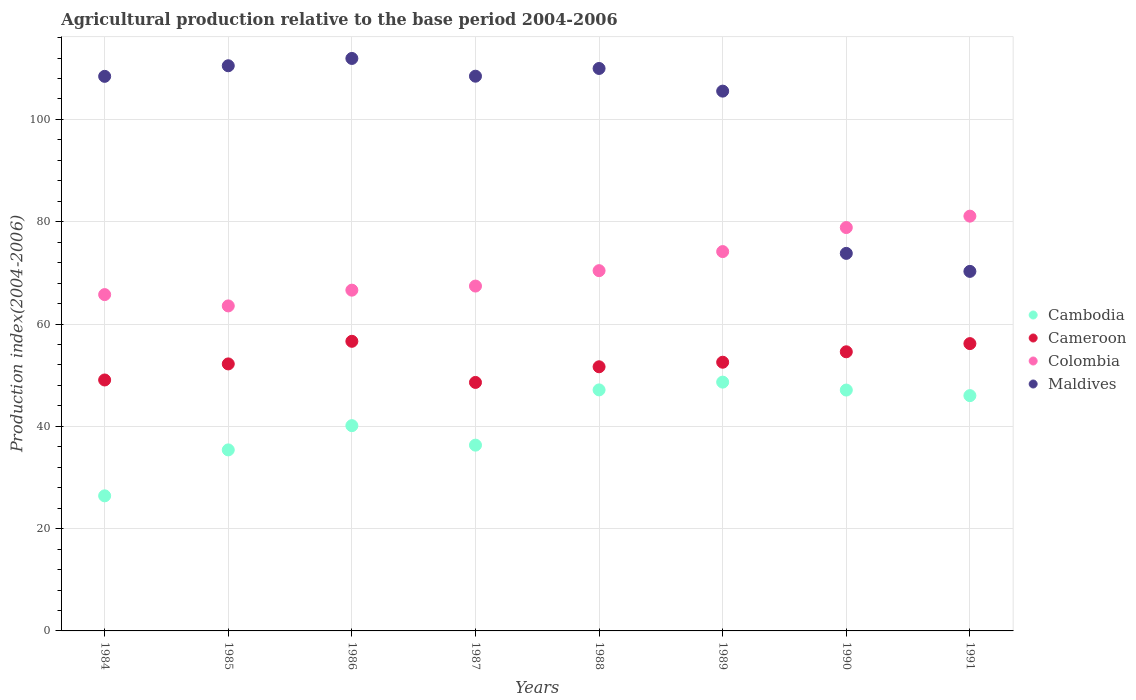How many different coloured dotlines are there?
Provide a short and direct response. 4. Is the number of dotlines equal to the number of legend labels?
Keep it short and to the point. Yes. What is the agricultural production index in Cambodia in 1988?
Your answer should be very brief. 47.12. Across all years, what is the maximum agricultural production index in Cambodia?
Ensure brevity in your answer.  48.64. Across all years, what is the minimum agricultural production index in Colombia?
Keep it short and to the point. 63.54. In which year was the agricultural production index in Cameroon maximum?
Your answer should be compact. 1986. In which year was the agricultural production index in Cameroon minimum?
Give a very brief answer. 1987. What is the total agricultural production index in Cameroon in the graph?
Your answer should be compact. 421.37. What is the difference between the agricultural production index in Cambodia in 1986 and that in 1991?
Your answer should be very brief. -5.87. What is the difference between the agricultural production index in Cambodia in 1984 and the agricultural production index in Maldives in 1988?
Provide a short and direct response. -83.55. What is the average agricultural production index in Colombia per year?
Give a very brief answer. 70.98. In the year 1991, what is the difference between the agricultural production index in Cambodia and agricultural production index in Colombia?
Provide a short and direct response. -35.09. What is the ratio of the agricultural production index in Cambodia in 1985 to that in 1991?
Give a very brief answer. 0.77. Is the agricultural production index in Maldives in 1984 less than that in 1988?
Your response must be concise. Yes. What is the difference between the highest and the second highest agricultural production index in Maldives?
Ensure brevity in your answer.  1.43. What is the difference between the highest and the lowest agricultural production index in Cambodia?
Keep it short and to the point. 22.23. In how many years, is the agricultural production index in Maldives greater than the average agricultural production index in Maldives taken over all years?
Make the answer very short. 6. Is the sum of the agricultural production index in Cameroon in 1987 and 1988 greater than the maximum agricultural production index in Cambodia across all years?
Your answer should be very brief. Yes. Does the agricultural production index in Cambodia monotonically increase over the years?
Give a very brief answer. No. Is the agricultural production index in Colombia strictly greater than the agricultural production index in Maldives over the years?
Keep it short and to the point. No. Is the agricultural production index in Colombia strictly less than the agricultural production index in Cambodia over the years?
Keep it short and to the point. No. How many dotlines are there?
Provide a succinct answer. 4. Does the graph contain any zero values?
Give a very brief answer. No. Does the graph contain grids?
Ensure brevity in your answer.  Yes. Where does the legend appear in the graph?
Keep it short and to the point. Center right. What is the title of the graph?
Provide a succinct answer. Agricultural production relative to the base period 2004-2006. What is the label or title of the Y-axis?
Your response must be concise. Production index(2004-2006). What is the Production index(2004-2006) of Cambodia in 1984?
Offer a terse response. 26.41. What is the Production index(2004-2006) in Cameroon in 1984?
Offer a very short reply. 49.06. What is the Production index(2004-2006) of Colombia in 1984?
Give a very brief answer. 65.75. What is the Production index(2004-2006) in Maldives in 1984?
Your answer should be compact. 108.42. What is the Production index(2004-2006) of Cambodia in 1985?
Provide a short and direct response. 35.39. What is the Production index(2004-2006) in Cameroon in 1985?
Your answer should be compact. 52.2. What is the Production index(2004-2006) in Colombia in 1985?
Offer a terse response. 63.54. What is the Production index(2004-2006) of Maldives in 1985?
Make the answer very short. 110.49. What is the Production index(2004-2006) in Cambodia in 1986?
Your response must be concise. 40.13. What is the Production index(2004-2006) in Cameroon in 1986?
Your answer should be compact. 56.62. What is the Production index(2004-2006) in Colombia in 1986?
Give a very brief answer. 66.62. What is the Production index(2004-2006) of Maldives in 1986?
Provide a short and direct response. 111.92. What is the Production index(2004-2006) in Cambodia in 1987?
Your response must be concise. 36.32. What is the Production index(2004-2006) in Cameroon in 1987?
Provide a succinct answer. 48.58. What is the Production index(2004-2006) of Colombia in 1987?
Make the answer very short. 67.42. What is the Production index(2004-2006) in Maldives in 1987?
Keep it short and to the point. 108.45. What is the Production index(2004-2006) in Cambodia in 1988?
Give a very brief answer. 47.12. What is the Production index(2004-2006) of Cameroon in 1988?
Provide a succinct answer. 51.64. What is the Production index(2004-2006) of Colombia in 1988?
Offer a very short reply. 70.43. What is the Production index(2004-2006) in Maldives in 1988?
Provide a succinct answer. 109.96. What is the Production index(2004-2006) in Cambodia in 1989?
Keep it short and to the point. 48.64. What is the Production index(2004-2006) in Cameroon in 1989?
Your response must be concise. 52.53. What is the Production index(2004-2006) of Colombia in 1989?
Your response must be concise. 74.16. What is the Production index(2004-2006) of Maldives in 1989?
Make the answer very short. 105.53. What is the Production index(2004-2006) in Cambodia in 1990?
Your response must be concise. 47.09. What is the Production index(2004-2006) of Cameroon in 1990?
Provide a short and direct response. 54.57. What is the Production index(2004-2006) in Colombia in 1990?
Your answer should be very brief. 78.86. What is the Production index(2004-2006) of Maldives in 1990?
Provide a succinct answer. 73.81. What is the Production index(2004-2006) of Cambodia in 1991?
Your answer should be very brief. 46. What is the Production index(2004-2006) in Cameroon in 1991?
Ensure brevity in your answer.  56.17. What is the Production index(2004-2006) of Colombia in 1991?
Provide a succinct answer. 81.09. What is the Production index(2004-2006) of Maldives in 1991?
Your response must be concise. 70.29. Across all years, what is the maximum Production index(2004-2006) of Cambodia?
Offer a very short reply. 48.64. Across all years, what is the maximum Production index(2004-2006) in Cameroon?
Your answer should be very brief. 56.62. Across all years, what is the maximum Production index(2004-2006) in Colombia?
Provide a succinct answer. 81.09. Across all years, what is the maximum Production index(2004-2006) in Maldives?
Offer a terse response. 111.92. Across all years, what is the minimum Production index(2004-2006) in Cambodia?
Your answer should be compact. 26.41. Across all years, what is the minimum Production index(2004-2006) in Cameroon?
Your response must be concise. 48.58. Across all years, what is the minimum Production index(2004-2006) of Colombia?
Make the answer very short. 63.54. Across all years, what is the minimum Production index(2004-2006) of Maldives?
Offer a very short reply. 70.29. What is the total Production index(2004-2006) of Cambodia in the graph?
Ensure brevity in your answer.  327.1. What is the total Production index(2004-2006) in Cameroon in the graph?
Ensure brevity in your answer.  421.37. What is the total Production index(2004-2006) in Colombia in the graph?
Your response must be concise. 567.87. What is the total Production index(2004-2006) in Maldives in the graph?
Provide a short and direct response. 798.87. What is the difference between the Production index(2004-2006) of Cambodia in 1984 and that in 1985?
Offer a very short reply. -8.98. What is the difference between the Production index(2004-2006) of Cameroon in 1984 and that in 1985?
Your answer should be compact. -3.14. What is the difference between the Production index(2004-2006) of Colombia in 1984 and that in 1985?
Provide a succinct answer. 2.21. What is the difference between the Production index(2004-2006) in Maldives in 1984 and that in 1985?
Keep it short and to the point. -2.07. What is the difference between the Production index(2004-2006) in Cambodia in 1984 and that in 1986?
Ensure brevity in your answer.  -13.72. What is the difference between the Production index(2004-2006) in Cameroon in 1984 and that in 1986?
Offer a terse response. -7.56. What is the difference between the Production index(2004-2006) in Colombia in 1984 and that in 1986?
Your answer should be compact. -0.87. What is the difference between the Production index(2004-2006) in Maldives in 1984 and that in 1986?
Offer a very short reply. -3.5. What is the difference between the Production index(2004-2006) of Cambodia in 1984 and that in 1987?
Provide a succinct answer. -9.91. What is the difference between the Production index(2004-2006) of Cameroon in 1984 and that in 1987?
Your response must be concise. 0.48. What is the difference between the Production index(2004-2006) of Colombia in 1984 and that in 1987?
Give a very brief answer. -1.67. What is the difference between the Production index(2004-2006) of Maldives in 1984 and that in 1987?
Your answer should be very brief. -0.03. What is the difference between the Production index(2004-2006) of Cambodia in 1984 and that in 1988?
Offer a very short reply. -20.71. What is the difference between the Production index(2004-2006) in Cameroon in 1984 and that in 1988?
Your answer should be compact. -2.58. What is the difference between the Production index(2004-2006) of Colombia in 1984 and that in 1988?
Make the answer very short. -4.68. What is the difference between the Production index(2004-2006) of Maldives in 1984 and that in 1988?
Your answer should be very brief. -1.54. What is the difference between the Production index(2004-2006) of Cambodia in 1984 and that in 1989?
Ensure brevity in your answer.  -22.23. What is the difference between the Production index(2004-2006) of Cameroon in 1984 and that in 1989?
Your answer should be very brief. -3.47. What is the difference between the Production index(2004-2006) of Colombia in 1984 and that in 1989?
Your response must be concise. -8.41. What is the difference between the Production index(2004-2006) in Maldives in 1984 and that in 1989?
Keep it short and to the point. 2.89. What is the difference between the Production index(2004-2006) in Cambodia in 1984 and that in 1990?
Give a very brief answer. -20.68. What is the difference between the Production index(2004-2006) of Cameroon in 1984 and that in 1990?
Keep it short and to the point. -5.51. What is the difference between the Production index(2004-2006) in Colombia in 1984 and that in 1990?
Ensure brevity in your answer.  -13.11. What is the difference between the Production index(2004-2006) in Maldives in 1984 and that in 1990?
Provide a short and direct response. 34.61. What is the difference between the Production index(2004-2006) of Cambodia in 1984 and that in 1991?
Offer a very short reply. -19.59. What is the difference between the Production index(2004-2006) in Cameroon in 1984 and that in 1991?
Offer a terse response. -7.11. What is the difference between the Production index(2004-2006) of Colombia in 1984 and that in 1991?
Your response must be concise. -15.34. What is the difference between the Production index(2004-2006) in Maldives in 1984 and that in 1991?
Offer a terse response. 38.13. What is the difference between the Production index(2004-2006) in Cambodia in 1985 and that in 1986?
Your response must be concise. -4.74. What is the difference between the Production index(2004-2006) of Cameroon in 1985 and that in 1986?
Offer a terse response. -4.42. What is the difference between the Production index(2004-2006) in Colombia in 1985 and that in 1986?
Ensure brevity in your answer.  -3.08. What is the difference between the Production index(2004-2006) of Maldives in 1985 and that in 1986?
Ensure brevity in your answer.  -1.43. What is the difference between the Production index(2004-2006) of Cambodia in 1985 and that in 1987?
Offer a very short reply. -0.93. What is the difference between the Production index(2004-2006) of Cameroon in 1985 and that in 1987?
Your answer should be compact. 3.62. What is the difference between the Production index(2004-2006) in Colombia in 1985 and that in 1987?
Offer a very short reply. -3.88. What is the difference between the Production index(2004-2006) of Maldives in 1985 and that in 1987?
Offer a very short reply. 2.04. What is the difference between the Production index(2004-2006) in Cambodia in 1985 and that in 1988?
Make the answer very short. -11.73. What is the difference between the Production index(2004-2006) of Cameroon in 1985 and that in 1988?
Offer a very short reply. 0.56. What is the difference between the Production index(2004-2006) in Colombia in 1985 and that in 1988?
Keep it short and to the point. -6.89. What is the difference between the Production index(2004-2006) of Maldives in 1985 and that in 1988?
Keep it short and to the point. 0.53. What is the difference between the Production index(2004-2006) of Cambodia in 1985 and that in 1989?
Provide a succinct answer. -13.25. What is the difference between the Production index(2004-2006) in Cameroon in 1985 and that in 1989?
Ensure brevity in your answer.  -0.33. What is the difference between the Production index(2004-2006) in Colombia in 1985 and that in 1989?
Your response must be concise. -10.62. What is the difference between the Production index(2004-2006) of Maldives in 1985 and that in 1989?
Your answer should be very brief. 4.96. What is the difference between the Production index(2004-2006) in Cameroon in 1985 and that in 1990?
Your answer should be compact. -2.37. What is the difference between the Production index(2004-2006) of Colombia in 1985 and that in 1990?
Ensure brevity in your answer.  -15.32. What is the difference between the Production index(2004-2006) of Maldives in 1985 and that in 1990?
Keep it short and to the point. 36.68. What is the difference between the Production index(2004-2006) of Cambodia in 1985 and that in 1991?
Offer a terse response. -10.61. What is the difference between the Production index(2004-2006) of Cameroon in 1985 and that in 1991?
Your answer should be compact. -3.97. What is the difference between the Production index(2004-2006) of Colombia in 1985 and that in 1991?
Your response must be concise. -17.55. What is the difference between the Production index(2004-2006) in Maldives in 1985 and that in 1991?
Give a very brief answer. 40.2. What is the difference between the Production index(2004-2006) of Cambodia in 1986 and that in 1987?
Your answer should be compact. 3.81. What is the difference between the Production index(2004-2006) of Cameroon in 1986 and that in 1987?
Give a very brief answer. 8.04. What is the difference between the Production index(2004-2006) in Maldives in 1986 and that in 1987?
Provide a short and direct response. 3.47. What is the difference between the Production index(2004-2006) in Cambodia in 1986 and that in 1988?
Provide a short and direct response. -6.99. What is the difference between the Production index(2004-2006) of Cameroon in 1986 and that in 1988?
Offer a very short reply. 4.98. What is the difference between the Production index(2004-2006) in Colombia in 1986 and that in 1988?
Give a very brief answer. -3.81. What is the difference between the Production index(2004-2006) of Maldives in 1986 and that in 1988?
Offer a very short reply. 1.96. What is the difference between the Production index(2004-2006) in Cambodia in 1986 and that in 1989?
Offer a terse response. -8.51. What is the difference between the Production index(2004-2006) in Cameroon in 1986 and that in 1989?
Give a very brief answer. 4.09. What is the difference between the Production index(2004-2006) in Colombia in 1986 and that in 1989?
Make the answer very short. -7.54. What is the difference between the Production index(2004-2006) of Maldives in 1986 and that in 1989?
Provide a short and direct response. 6.39. What is the difference between the Production index(2004-2006) in Cambodia in 1986 and that in 1990?
Your response must be concise. -6.96. What is the difference between the Production index(2004-2006) of Cameroon in 1986 and that in 1990?
Your response must be concise. 2.05. What is the difference between the Production index(2004-2006) of Colombia in 1986 and that in 1990?
Your answer should be compact. -12.24. What is the difference between the Production index(2004-2006) in Maldives in 1986 and that in 1990?
Provide a succinct answer. 38.11. What is the difference between the Production index(2004-2006) of Cambodia in 1986 and that in 1991?
Provide a succinct answer. -5.87. What is the difference between the Production index(2004-2006) of Cameroon in 1986 and that in 1991?
Your answer should be compact. 0.45. What is the difference between the Production index(2004-2006) of Colombia in 1986 and that in 1991?
Your answer should be compact. -14.47. What is the difference between the Production index(2004-2006) in Maldives in 1986 and that in 1991?
Offer a terse response. 41.63. What is the difference between the Production index(2004-2006) in Cambodia in 1987 and that in 1988?
Provide a succinct answer. -10.8. What is the difference between the Production index(2004-2006) in Cameroon in 1987 and that in 1988?
Your response must be concise. -3.06. What is the difference between the Production index(2004-2006) in Colombia in 1987 and that in 1988?
Offer a very short reply. -3.01. What is the difference between the Production index(2004-2006) of Maldives in 1987 and that in 1988?
Keep it short and to the point. -1.51. What is the difference between the Production index(2004-2006) in Cambodia in 1987 and that in 1989?
Offer a terse response. -12.32. What is the difference between the Production index(2004-2006) of Cameroon in 1987 and that in 1989?
Your answer should be compact. -3.95. What is the difference between the Production index(2004-2006) in Colombia in 1987 and that in 1989?
Your answer should be compact. -6.74. What is the difference between the Production index(2004-2006) of Maldives in 1987 and that in 1989?
Your answer should be compact. 2.92. What is the difference between the Production index(2004-2006) of Cambodia in 1987 and that in 1990?
Offer a very short reply. -10.77. What is the difference between the Production index(2004-2006) in Cameroon in 1987 and that in 1990?
Give a very brief answer. -5.99. What is the difference between the Production index(2004-2006) in Colombia in 1987 and that in 1990?
Make the answer very short. -11.44. What is the difference between the Production index(2004-2006) of Maldives in 1987 and that in 1990?
Your response must be concise. 34.64. What is the difference between the Production index(2004-2006) of Cambodia in 1987 and that in 1991?
Your response must be concise. -9.68. What is the difference between the Production index(2004-2006) of Cameroon in 1987 and that in 1991?
Offer a very short reply. -7.59. What is the difference between the Production index(2004-2006) of Colombia in 1987 and that in 1991?
Provide a succinct answer. -13.67. What is the difference between the Production index(2004-2006) of Maldives in 1987 and that in 1991?
Offer a terse response. 38.16. What is the difference between the Production index(2004-2006) of Cambodia in 1988 and that in 1989?
Ensure brevity in your answer.  -1.52. What is the difference between the Production index(2004-2006) in Cameroon in 1988 and that in 1989?
Your answer should be compact. -0.89. What is the difference between the Production index(2004-2006) in Colombia in 1988 and that in 1989?
Make the answer very short. -3.73. What is the difference between the Production index(2004-2006) in Maldives in 1988 and that in 1989?
Ensure brevity in your answer.  4.43. What is the difference between the Production index(2004-2006) of Cameroon in 1988 and that in 1990?
Your answer should be compact. -2.93. What is the difference between the Production index(2004-2006) in Colombia in 1988 and that in 1990?
Provide a succinct answer. -8.43. What is the difference between the Production index(2004-2006) in Maldives in 1988 and that in 1990?
Keep it short and to the point. 36.15. What is the difference between the Production index(2004-2006) in Cambodia in 1988 and that in 1991?
Provide a short and direct response. 1.12. What is the difference between the Production index(2004-2006) of Cameroon in 1988 and that in 1991?
Keep it short and to the point. -4.53. What is the difference between the Production index(2004-2006) in Colombia in 1988 and that in 1991?
Ensure brevity in your answer.  -10.66. What is the difference between the Production index(2004-2006) of Maldives in 1988 and that in 1991?
Give a very brief answer. 39.67. What is the difference between the Production index(2004-2006) of Cambodia in 1989 and that in 1990?
Your response must be concise. 1.55. What is the difference between the Production index(2004-2006) in Cameroon in 1989 and that in 1990?
Ensure brevity in your answer.  -2.04. What is the difference between the Production index(2004-2006) of Colombia in 1989 and that in 1990?
Give a very brief answer. -4.7. What is the difference between the Production index(2004-2006) of Maldives in 1989 and that in 1990?
Offer a terse response. 31.72. What is the difference between the Production index(2004-2006) of Cambodia in 1989 and that in 1991?
Provide a succinct answer. 2.64. What is the difference between the Production index(2004-2006) in Cameroon in 1989 and that in 1991?
Make the answer very short. -3.64. What is the difference between the Production index(2004-2006) in Colombia in 1989 and that in 1991?
Your response must be concise. -6.93. What is the difference between the Production index(2004-2006) in Maldives in 1989 and that in 1991?
Give a very brief answer. 35.24. What is the difference between the Production index(2004-2006) in Cambodia in 1990 and that in 1991?
Ensure brevity in your answer.  1.09. What is the difference between the Production index(2004-2006) in Cameroon in 1990 and that in 1991?
Give a very brief answer. -1.6. What is the difference between the Production index(2004-2006) in Colombia in 1990 and that in 1991?
Your answer should be compact. -2.23. What is the difference between the Production index(2004-2006) in Maldives in 1990 and that in 1991?
Offer a terse response. 3.52. What is the difference between the Production index(2004-2006) of Cambodia in 1984 and the Production index(2004-2006) of Cameroon in 1985?
Keep it short and to the point. -25.79. What is the difference between the Production index(2004-2006) in Cambodia in 1984 and the Production index(2004-2006) in Colombia in 1985?
Provide a short and direct response. -37.13. What is the difference between the Production index(2004-2006) of Cambodia in 1984 and the Production index(2004-2006) of Maldives in 1985?
Your response must be concise. -84.08. What is the difference between the Production index(2004-2006) of Cameroon in 1984 and the Production index(2004-2006) of Colombia in 1985?
Provide a succinct answer. -14.48. What is the difference between the Production index(2004-2006) of Cameroon in 1984 and the Production index(2004-2006) of Maldives in 1985?
Offer a terse response. -61.43. What is the difference between the Production index(2004-2006) in Colombia in 1984 and the Production index(2004-2006) in Maldives in 1985?
Your answer should be very brief. -44.74. What is the difference between the Production index(2004-2006) in Cambodia in 1984 and the Production index(2004-2006) in Cameroon in 1986?
Keep it short and to the point. -30.21. What is the difference between the Production index(2004-2006) of Cambodia in 1984 and the Production index(2004-2006) of Colombia in 1986?
Offer a terse response. -40.21. What is the difference between the Production index(2004-2006) of Cambodia in 1984 and the Production index(2004-2006) of Maldives in 1986?
Give a very brief answer. -85.51. What is the difference between the Production index(2004-2006) in Cameroon in 1984 and the Production index(2004-2006) in Colombia in 1986?
Your answer should be very brief. -17.56. What is the difference between the Production index(2004-2006) in Cameroon in 1984 and the Production index(2004-2006) in Maldives in 1986?
Provide a succinct answer. -62.86. What is the difference between the Production index(2004-2006) of Colombia in 1984 and the Production index(2004-2006) of Maldives in 1986?
Keep it short and to the point. -46.17. What is the difference between the Production index(2004-2006) of Cambodia in 1984 and the Production index(2004-2006) of Cameroon in 1987?
Your response must be concise. -22.17. What is the difference between the Production index(2004-2006) of Cambodia in 1984 and the Production index(2004-2006) of Colombia in 1987?
Make the answer very short. -41.01. What is the difference between the Production index(2004-2006) of Cambodia in 1984 and the Production index(2004-2006) of Maldives in 1987?
Your answer should be very brief. -82.04. What is the difference between the Production index(2004-2006) in Cameroon in 1984 and the Production index(2004-2006) in Colombia in 1987?
Keep it short and to the point. -18.36. What is the difference between the Production index(2004-2006) of Cameroon in 1984 and the Production index(2004-2006) of Maldives in 1987?
Provide a short and direct response. -59.39. What is the difference between the Production index(2004-2006) in Colombia in 1984 and the Production index(2004-2006) in Maldives in 1987?
Your answer should be compact. -42.7. What is the difference between the Production index(2004-2006) of Cambodia in 1984 and the Production index(2004-2006) of Cameroon in 1988?
Ensure brevity in your answer.  -25.23. What is the difference between the Production index(2004-2006) of Cambodia in 1984 and the Production index(2004-2006) of Colombia in 1988?
Your response must be concise. -44.02. What is the difference between the Production index(2004-2006) in Cambodia in 1984 and the Production index(2004-2006) in Maldives in 1988?
Your response must be concise. -83.55. What is the difference between the Production index(2004-2006) of Cameroon in 1984 and the Production index(2004-2006) of Colombia in 1988?
Give a very brief answer. -21.37. What is the difference between the Production index(2004-2006) in Cameroon in 1984 and the Production index(2004-2006) in Maldives in 1988?
Offer a very short reply. -60.9. What is the difference between the Production index(2004-2006) in Colombia in 1984 and the Production index(2004-2006) in Maldives in 1988?
Keep it short and to the point. -44.21. What is the difference between the Production index(2004-2006) in Cambodia in 1984 and the Production index(2004-2006) in Cameroon in 1989?
Your response must be concise. -26.12. What is the difference between the Production index(2004-2006) of Cambodia in 1984 and the Production index(2004-2006) of Colombia in 1989?
Offer a very short reply. -47.75. What is the difference between the Production index(2004-2006) in Cambodia in 1984 and the Production index(2004-2006) in Maldives in 1989?
Offer a terse response. -79.12. What is the difference between the Production index(2004-2006) in Cameroon in 1984 and the Production index(2004-2006) in Colombia in 1989?
Offer a terse response. -25.1. What is the difference between the Production index(2004-2006) in Cameroon in 1984 and the Production index(2004-2006) in Maldives in 1989?
Provide a succinct answer. -56.47. What is the difference between the Production index(2004-2006) of Colombia in 1984 and the Production index(2004-2006) of Maldives in 1989?
Give a very brief answer. -39.78. What is the difference between the Production index(2004-2006) of Cambodia in 1984 and the Production index(2004-2006) of Cameroon in 1990?
Offer a terse response. -28.16. What is the difference between the Production index(2004-2006) in Cambodia in 1984 and the Production index(2004-2006) in Colombia in 1990?
Give a very brief answer. -52.45. What is the difference between the Production index(2004-2006) of Cambodia in 1984 and the Production index(2004-2006) of Maldives in 1990?
Provide a short and direct response. -47.4. What is the difference between the Production index(2004-2006) in Cameroon in 1984 and the Production index(2004-2006) in Colombia in 1990?
Your answer should be compact. -29.8. What is the difference between the Production index(2004-2006) of Cameroon in 1984 and the Production index(2004-2006) of Maldives in 1990?
Give a very brief answer. -24.75. What is the difference between the Production index(2004-2006) in Colombia in 1984 and the Production index(2004-2006) in Maldives in 1990?
Offer a terse response. -8.06. What is the difference between the Production index(2004-2006) in Cambodia in 1984 and the Production index(2004-2006) in Cameroon in 1991?
Provide a short and direct response. -29.76. What is the difference between the Production index(2004-2006) of Cambodia in 1984 and the Production index(2004-2006) of Colombia in 1991?
Keep it short and to the point. -54.68. What is the difference between the Production index(2004-2006) in Cambodia in 1984 and the Production index(2004-2006) in Maldives in 1991?
Make the answer very short. -43.88. What is the difference between the Production index(2004-2006) in Cameroon in 1984 and the Production index(2004-2006) in Colombia in 1991?
Provide a short and direct response. -32.03. What is the difference between the Production index(2004-2006) of Cameroon in 1984 and the Production index(2004-2006) of Maldives in 1991?
Ensure brevity in your answer.  -21.23. What is the difference between the Production index(2004-2006) in Colombia in 1984 and the Production index(2004-2006) in Maldives in 1991?
Provide a short and direct response. -4.54. What is the difference between the Production index(2004-2006) in Cambodia in 1985 and the Production index(2004-2006) in Cameroon in 1986?
Your answer should be very brief. -21.23. What is the difference between the Production index(2004-2006) in Cambodia in 1985 and the Production index(2004-2006) in Colombia in 1986?
Your response must be concise. -31.23. What is the difference between the Production index(2004-2006) in Cambodia in 1985 and the Production index(2004-2006) in Maldives in 1986?
Keep it short and to the point. -76.53. What is the difference between the Production index(2004-2006) of Cameroon in 1985 and the Production index(2004-2006) of Colombia in 1986?
Provide a short and direct response. -14.42. What is the difference between the Production index(2004-2006) in Cameroon in 1985 and the Production index(2004-2006) in Maldives in 1986?
Offer a terse response. -59.72. What is the difference between the Production index(2004-2006) of Colombia in 1985 and the Production index(2004-2006) of Maldives in 1986?
Provide a succinct answer. -48.38. What is the difference between the Production index(2004-2006) in Cambodia in 1985 and the Production index(2004-2006) in Cameroon in 1987?
Offer a terse response. -13.19. What is the difference between the Production index(2004-2006) in Cambodia in 1985 and the Production index(2004-2006) in Colombia in 1987?
Keep it short and to the point. -32.03. What is the difference between the Production index(2004-2006) of Cambodia in 1985 and the Production index(2004-2006) of Maldives in 1987?
Make the answer very short. -73.06. What is the difference between the Production index(2004-2006) in Cameroon in 1985 and the Production index(2004-2006) in Colombia in 1987?
Your response must be concise. -15.22. What is the difference between the Production index(2004-2006) in Cameroon in 1985 and the Production index(2004-2006) in Maldives in 1987?
Keep it short and to the point. -56.25. What is the difference between the Production index(2004-2006) of Colombia in 1985 and the Production index(2004-2006) of Maldives in 1987?
Your response must be concise. -44.91. What is the difference between the Production index(2004-2006) in Cambodia in 1985 and the Production index(2004-2006) in Cameroon in 1988?
Provide a short and direct response. -16.25. What is the difference between the Production index(2004-2006) in Cambodia in 1985 and the Production index(2004-2006) in Colombia in 1988?
Keep it short and to the point. -35.04. What is the difference between the Production index(2004-2006) of Cambodia in 1985 and the Production index(2004-2006) of Maldives in 1988?
Ensure brevity in your answer.  -74.57. What is the difference between the Production index(2004-2006) of Cameroon in 1985 and the Production index(2004-2006) of Colombia in 1988?
Offer a very short reply. -18.23. What is the difference between the Production index(2004-2006) of Cameroon in 1985 and the Production index(2004-2006) of Maldives in 1988?
Make the answer very short. -57.76. What is the difference between the Production index(2004-2006) of Colombia in 1985 and the Production index(2004-2006) of Maldives in 1988?
Offer a very short reply. -46.42. What is the difference between the Production index(2004-2006) of Cambodia in 1985 and the Production index(2004-2006) of Cameroon in 1989?
Offer a terse response. -17.14. What is the difference between the Production index(2004-2006) of Cambodia in 1985 and the Production index(2004-2006) of Colombia in 1989?
Your answer should be compact. -38.77. What is the difference between the Production index(2004-2006) in Cambodia in 1985 and the Production index(2004-2006) in Maldives in 1989?
Provide a succinct answer. -70.14. What is the difference between the Production index(2004-2006) of Cameroon in 1985 and the Production index(2004-2006) of Colombia in 1989?
Provide a short and direct response. -21.96. What is the difference between the Production index(2004-2006) in Cameroon in 1985 and the Production index(2004-2006) in Maldives in 1989?
Ensure brevity in your answer.  -53.33. What is the difference between the Production index(2004-2006) of Colombia in 1985 and the Production index(2004-2006) of Maldives in 1989?
Provide a short and direct response. -41.99. What is the difference between the Production index(2004-2006) in Cambodia in 1985 and the Production index(2004-2006) in Cameroon in 1990?
Offer a very short reply. -19.18. What is the difference between the Production index(2004-2006) in Cambodia in 1985 and the Production index(2004-2006) in Colombia in 1990?
Your response must be concise. -43.47. What is the difference between the Production index(2004-2006) in Cambodia in 1985 and the Production index(2004-2006) in Maldives in 1990?
Keep it short and to the point. -38.42. What is the difference between the Production index(2004-2006) of Cameroon in 1985 and the Production index(2004-2006) of Colombia in 1990?
Keep it short and to the point. -26.66. What is the difference between the Production index(2004-2006) in Cameroon in 1985 and the Production index(2004-2006) in Maldives in 1990?
Your answer should be compact. -21.61. What is the difference between the Production index(2004-2006) of Colombia in 1985 and the Production index(2004-2006) of Maldives in 1990?
Give a very brief answer. -10.27. What is the difference between the Production index(2004-2006) in Cambodia in 1985 and the Production index(2004-2006) in Cameroon in 1991?
Ensure brevity in your answer.  -20.78. What is the difference between the Production index(2004-2006) of Cambodia in 1985 and the Production index(2004-2006) of Colombia in 1991?
Ensure brevity in your answer.  -45.7. What is the difference between the Production index(2004-2006) of Cambodia in 1985 and the Production index(2004-2006) of Maldives in 1991?
Offer a very short reply. -34.9. What is the difference between the Production index(2004-2006) in Cameroon in 1985 and the Production index(2004-2006) in Colombia in 1991?
Your answer should be compact. -28.89. What is the difference between the Production index(2004-2006) of Cameroon in 1985 and the Production index(2004-2006) of Maldives in 1991?
Your response must be concise. -18.09. What is the difference between the Production index(2004-2006) in Colombia in 1985 and the Production index(2004-2006) in Maldives in 1991?
Provide a short and direct response. -6.75. What is the difference between the Production index(2004-2006) of Cambodia in 1986 and the Production index(2004-2006) of Cameroon in 1987?
Make the answer very short. -8.45. What is the difference between the Production index(2004-2006) in Cambodia in 1986 and the Production index(2004-2006) in Colombia in 1987?
Provide a succinct answer. -27.29. What is the difference between the Production index(2004-2006) in Cambodia in 1986 and the Production index(2004-2006) in Maldives in 1987?
Ensure brevity in your answer.  -68.32. What is the difference between the Production index(2004-2006) of Cameroon in 1986 and the Production index(2004-2006) of Maldives in 1987?
Your response must be concise. -51.83. What is the difference between the Production index(2004-2006) of Colombia in 1986 and the Production index(2004-2006) of Maldives in 1987?
Offer a very short reply. -41.83. What is the difference between the Production index(2004-2006) in Cambodia in 1986 and the Production index(2004-2006) in Cameroon in 1988?
Ensure brevity in your answer.  -11.51. What is the difference between the Production index(2004-2006) in Cambodia in 1986 and the Production index(2004-2006) in Colombia in 1988?
Give a very brief answer. -30.3. What is the difference between the Production index(2004-2006) in Cambodia in 1986 and the Production index(2004-2006) in Maldives in 1988?
Keep it short and to the point. -69.83. What is the difference between the Production index(2004-2006) of Cameroon in 1986 and the Production index(2004-2006) of Colombia in 1988?
Make the answer very short. -13.81. What is the difference between the Production index(2004-2006) of Cameroon in 1986 and the Production index(2004-2006) of Maldives in 1988?
Provide a short and direct response. -53.34. What is the difference between the Production index(2004-2006) in Colombia in 1986 and the Production index(2004-2006) in Maldives in 1988?
Keep it short and to the point. -43.34. What is the difference between the Production index(2004-2006) in Cambodia in 1986 and the Production index(2004-2006) in Colombia in 1989?
Give a very brief answer. -34.03. What is the difference between the Production index(2004-2006) of Cambodia in 1986 and the Production index(2004-2006) of Maldives in 1989?
Your answer should be compact. -65.4. What is the difference between the Production index(2004-2006) of Cameroon in 1986 and the Production index(2004-2006) of Colombia in 1989?
Keep it short and to the point. -17.54. What is the difference between the Production index(2004-2006) in Cameroon in 1986 and the Production index(2004-2006) in Maldives in 1989?
Your response must be concise. -48.91. What is the difference between the Production index(2004-2006) of Colombia in 1986 and the Production index(2004-2006) of Maldives in 1989?
Offer a terse response. -38.91. What is the difference between the Production index(2004-2006) in Cambodia in 1986 and the Production index(2004-2006) in Cameroon in 1990?
Provide a succinct answer. -14.44. What is the difference between the Production index(2004-2006) of Cambodia in 1986 and the Production index(2004-2006) of Colombia in 1990?
Offer a terse response. -38.73. What is the difference between the Production index(2004-2006) of Cambodia in 1986 and the Production index(2004-2006) of Maldives in 1990?
Your answer should be compact. -33.68. What is the difference between the Production index(2004-2006) of Cameroon in 1986 and the Production index(2004-2006) of Colombia in 1990?
Give a very brief answer. -22.24. What is the difference between the Production index(2004-2006) of Cameroon in 1986 and the Production index(2004-2006) of Maldives in 1990?
Offer a very short reply. -17.19. What is the difference between the Production index(2004-2006) in Colombia in 1986 and the Production index(2004-2006) in Maldives in 1990?
Offer a terse response. -7.19. What is the difference between the Production index(2004-2006) in Cambodia in 1986 and the Production index(2004-2006) in Cameroon in 1991?
Make the answer very short. -16.04. What is the difference between the Production index(2004-2006) in Cambodia in 1986 and the Production index(2004-2006) in Colombia in 1991?
Your answer should be very brief. -40.96. What is the difference between the Production index(2004-2006) of Cambodia in 1986 and the Production index(2004-2006) of Maldives in 1991?
Provide a succinct answer. -30.16. What is the difference between the Production index(2004-2006) of Cameroon in 1986 and the Production index(2004-2006) of Colombia in 1991?
Make the answer very short. -24.47. What is the difference between the Production index(2004-2006) in Cameroon in 1986 and the Production index(2004-2006) in Maldives in 1991?
Offer a very short reply. -13.67. What is the difference between the Production index(2004-2006) of Colombia in 1986 and the Production index(2004-2006) of Maldives in 1991?
Ensure brevity in your answer.  -3.67. What is the difference between the Production index(2004-2006) of Cambodia in 1987 and the Production index(2004-2006) of Cameroon in 1988?
Your response must be concise. -15.32. What is the difference between the Production index(2004-2006) of Cambodia in 1987 and the Production index(2004-2006) of Colombia in 1988?
Keep it short and to the point. -34.11. What is the difference between the Production index(2004-2006) in Cambodia in 1987 and the Production index(2004-2006) in Maldives in 1988?
Keep it short and to the point. -73.64. What is the difference between the Production index(2004-2006) in Cameroon in 1987 and the Production index(2004-2006) in Colombia in 1988?
Provide a short and direct response. -21.85. What is the difference between the Production index(2004-2006) in Cameroon in 1987 and the Production index(2004-2006) in Maldives in 1988?
Keep it short and to the point. -61.38. What is the difference between the Production index(2004-2006) in Colombia in 1987 and the Production index(2004-2006) in Maldives in 1988?
Your answer should be very brief. -42.54. What is the difference between the Production index(2004-2006) in Cambodia in 1987 and the Production index(2004-2006) in Cameroon in 1989?
Your answer should be compact. -16.21. What is the difference between the Production index(2004-2006) in Cambodia in 1987 and the Production index(2004-2006) in Colombia in 1989?
Give a very brief answer. -37.84. What is the difference between the Production index(2004-2006) in Cambodia in 1987 and the Production index(2004-2006) in Maldives in 1989?
Your response must be concise. -69.21. What is the difference between the Production index(2004-2006) of Cameroon in 1987 and the Production index(2004-2006) of Colombia in 1989?
Your response must be concise. -25.58. What is the difference between the Production index(2004-2006) of Cameroon in 1987 and the Production index(2004-2006) of Maldives in 1989?
Your answer should be compact. -56.95. What is the difference between the Production index(2004-2006) of Colombia in 1987 and the Production index(2004-2006) of Maldives in 1989?
Make the answer very short. -38.11. What is the difference between the Production index(2004-2006) of Cambodia in 1987 and the Production index(2004-2006) of Cameroon in 1990?
Give a very brief answer. -18.25. What is the difference between the Production index(2004-2006) in Cambodia in 1987 and the Production index(2004-2006) in Colombia in 1990?
Ensure brevity in your answer.  -42.54. What is the difference between the Production index(2004-2006) in Cambodia in 1987 and the Production index(2004-2006) in Maldives in 1990?
Your answer should be compact. -37.49. What is the difference between the Production index(2004-2006) in Cameroon in 1987 and the Production index(2004-2006) in Colombia in 1990?
Ensure brevity in your answer.  -30.28. What is the difference between the Production index(2004-2006) of Cameroon in 1987 and the Production index(2004-2006) of Maldives in 1990?
Offer a very short reply. -25.23. What is the difference between the Production index(2004-2006) in Colombia in 1987 and the Production index(2004-2006) in Maldives in 1990?
Your answer should be compact. -6.39. What is the difference between the Production index(2004-2006) of Cambodia in 1987 and the Production index(2004-2006) of Cameroon in 1991?
Your answer should be compact. -19.85. What is the difference between the Production index(2004-2006) of Cambodia in 1987 and the Production index(2004-2006) of Colombia in 1991?
Your answer should be compact. -44.77. What is the difference between the Production index(2004-2006) in Cambodia in 1987 and the Production index(2004-2006) in Maldives in 1991?
Your answer should be very brief. -33.97. What is the difference between the Production index(2004-2006) in Cameroon in 1987 and the Production index(2004-2006) in Colombia in 1991?
Your answer should be very brief. -32.51. What is the difference between the Production index(2004-2006) of Cameroon in 1987 and the Production index(2004-2006) of Maldives in 1991?
Your answer should be compact. -21.71. What is the difference between the Production index(2004-2006) of Colombia in 1987 and the Production index(2004-2006) of Maldives in 1991?
Your response must be concise. -2.87. What is the difference between the Production index(2004-2006) of Cambodia in 1988 and the Production index(2004-2006) of Cameroon in 1989?
Provide a succinct answer. -5.41. What is the difference between the Production index(2004-2006) of Cambodia in 1988 and the Production index(2004-2006) of Colombia in 1989?
Offer a terse response. -27.04. What is the difference between the Production index(2004-2006) in Cambodia in 1988 and the Production index(2004-2006) in Maldives in 1989?
Make the answer very short. -58.41. What is the difference between the Production index(2004-2006) in Cameroon in 1988 and the Production index(2004-2006) in Colombia in 1989?
Your answer should be compact. -22.52. What is the difference between the Production index(2004-2006) of Cameroon in 1988 and the Production index(2004-2006) of Maldives in 1989?
Offer a terse response. -53.89. What is the difference between the Production index(2004-2006) in Colombia in 1988 and the Production index(2004-2006) in Maldives in 1989?
Your response must be concise. -35.1. What is the difference between the Production index(2004-2006) in Cambodia in 1988 and the Production index(2004-2006) in Cameroon in 1990?
Give a very brief answer. -7.45. What is the difference between the Production index(2004-2006) of Cambodia in 1988 and the Production index(2004-2006) of Colombia in 1990?
Offer a very short reply. -31.74. What is the difference between the Production index(2004-2006) in Cambodia in 1988 and the Production index(2004-2006) in Maldives in 1990?
Offer a terse response. -26.69. What is the difference between the Production index(2004-2006) in Cameroon in 1988 and the Production index(2004-2006) in Colombia in 1990?
Ensure brevity in your answer.  -27.22. What is the difference between the Production index(2004-2006) of Cameroon in 1988 and the Production index(2004-2006) of Maldives in 1990?
Keep it short and to the point. -22.17. What is the difference between the Production index(2004-2006) in Colombia in 1988 and the Production index(2004-2006) in Maldives in 1990?
Your answer should be very brief. -3.38. What is the difference between the Production index(2004-2006) in Cambodia in 1988 and the Production index(2004-2006) in Cameroon in 1991?
Provide a short and direct response. -9.05. What is the difference between the Production index(2004-2006) of Cambodia in 1988 and the Production index(2004-2006) of Colombia in 1991?
Provide a succinct answer. -33.97. What is the difference between the Production index(2004-2006) of Cambodia in 1988 and the Production index(2004-2006) of Maldives in 1991?
Your answer should be very brief. -23.17. What is the difference between the Production index(2004-2006) in Cameroon in 1988 and the Production index(2004-2006) in Colombia in 1991?
Provide a succinct answer. -29.45. What is the difference between the Production index(2004-2006) in Cameroon in 1988 and the Production index(2004-2006) in Maldives in 1991?
Your answer should be very brief. -18.65. What is the difference between the Production index(2004-2006) of Colombia in 1988 and the Production index(2004-2006) of Maldives in 1991?
Offer a very short reply. 0.14. What is the difference between the Production index(2004-2006) in Cambodia in 1989 and the Production index(2004-2006) in Cameroon in 1990?
Your answer should be very brief. -5.93. What is the difference between the Production index(2004-2006) in Cambodia in 1989 and the Production index(2004-2006) in Colombia in 1990?
Your response must be concise. -30.22. What is the difference between the Production index(2004-2006) in Cambodia in 1989 and the Production index(2004-2006) in Maldives in 1990?
Your response must be concise. -25.17. What is the difference between the Production index(2004-2006) in Cameroon in 1989 and the Production index(2004-2006) in Colombia in 1990?
Provide a short and direct response. -26.33. What is the difference between the Production index(2004-2006) of Cameroon in 1989 and the Production index(2004-2006) of Maldives in 1990?
Provide a short and direct response. -21.28. What is the difference between the Production index(2004-2006) in Colombia in 1989 and the Production index(2004-2006) in Maldives in 1990?
Provide a succinct answer. 0.35. What is the difference between the Production index(2004-2006) in Cambodia in 1989 and the Production index(2004-2006) in Cameroon in 1991?
Your answer should be very brief. -7.53. What is the difference between the Production index(2004-2006) in Cambodia in 1989 and the Production index(2004-2006) in Colombia in 1991?
Ensure brevity in your answer.  -32.45. What is the difference between the Production index(2004-2006) of Cambodia in 1989 and the Production index(2004-2006) of Maldives in 1991?
Offer a terse response. -21.65. What is the difference between the Production index(2004-2006) of Cameroon in 1989 and the Production index(2004-2006) of Colombia in 1991?
Make the answer very short. -28.56. What is the difference between the Production index(2004-2006) in Cameroon in 1989 and the Production index(2004-2006) in Maldives in 1991?
Ensure brevity in your answer.  -17.76. What is the difference between the Production index(2004-2006) of Colombia in 1989 and the Production index(2004-2006) of Maldives in 1991?
Your answer should be very brief. 3.87. What is the difference between the Production index(2004-2006) in Cambodia in 1990 and the Production index(2004-2006) in Cameroon in 1991?
Make the answer very short. -9.08. What is the difference between the Production index(2004-2006) of Cambodia in 1990 and the Production index(2004-2006) of Colombia in 1991?
Keep it short and to the point. -34. What is the difference between the Production index(2004-2006) in Cambodia in 1990 and the Production index(2004-2006) in Maldives in 1991?
Provide a short and direct response. -23.2. What is the difference between the Production index(2004-2006) of Cameroon in 1990 and the Production index(2004-2006) of Colombia in 1991?
Offer a very short reply. -26.52. What is the difference between the Production index(2004-2006) in Cameroon in 1990 and the Production index(2004-2006) in Maldives in 1991?
Your response must be concise. -15.72. What is the difference between the Production index(2004-2006) in Colombia in 1990 and the Production index(2004-2006) in Maldives in 1991?
Your response must be concise. 8.57. What is the average Production index(2004-2006) in Cambodia per year?
Give a very brief answer. 40.89. What is the average Production index(2004-2006) of Cameroon per year?
Provide a short and direct response. 52.67. What is the average Production index(2004-2006) in Colombia per year?
Provide a succinct answer. 70.98. What is the average Production index(2004-2006) in Maldives per year?
Give a very brief answer. 99.86. In the year 1984, what is the difference between the Production index(2004-2006) of Cambodia and Production index(2004-2006) of Cameroon?
Your answer should be very brief. -22.65. In the year 1984, what is the difference between the Production index(2004-2006) of Cambodia and Production index(2004-2006) of Colombia?
Ensure brevity in your answer.  -39.34. In the year 1984, what is the difference between the Production index(2004-2006) in Cambodia and Production index(2004-2006) in Maldives?
Your answer should be very brief. -82.01. In the year 1984, what is the difference between the Production index(2004-2006) in Cameroon and Production index(2004-2006) in Colombia?
Your response must be concise. -16.69. In the year 1984, what is the difference between the Production index(2004-2006) in Cameroon and Production index(2004-2006) in Maldives?
Offer a very short reply. -59.36. In the year 1984, what is the difference between the Production index(2004-2006) of Colombia and Production index(2004-2006) of Maldives?
Your answer should be compact. -42.67. In the year 1985, what is the difference between the Production index(2004-2006) of Cambodia and Production index(2004-2006) of Cameroon?
Give a very brief answer. -16.81. In the year 1985, what is the difference between the Production index(2004-2006) in Cambodia and Production index(2004-2006) in Colombia?
Provide a short and direct response. -28.15. In the year 1985, what is the difference between the Production index(2004-2006) of Cambodia and Production index(2004-2006) of Maldives?
Make the answer very short. -75.1. In the year 1985, what is the difference between the Production index(2004-2006) of Cameroon and Production index(2004-2006) of Colombia?
Offer a very short reply. -11.34. In the year 1985, what is the difference between the Production index(2004-2006) in Cameroon and Production index(2004-2006) in Maldives?
Provide a succinct answer. -58.29. In the year 1985, what is the difference between the Production index(2004-2006) of Colombia and Production index(2004-2006) of Maldives?
Keep it short and to the point. -46.95. In the year 1986, what is the difference between the Production index(2004-2006) of Cambodia and Production index(2004-2006) of Cameroon?
Offer a terse response. -16.49. In the year 1986, what is the difference between the Production index(2004-2006) in Cambodia and Production index(2004-2006) in Colombia?
Your answer should be compact. -26.49. In the year 1986, what is the difference between the Production index(2004-2006) in Cambodia and Production index(2004-2006) in Maldives?
Your answer should be compact. -71.79. In the year 1986, what is the difference between the Production index(2004-2006) in Cameroon and Production index(2004-2006) in Maldives?
Your response must be concise. -55.3. In the year 1986, what is the difference between the Production index(2004-2006) of Colombia and Production index(2004-2006) of Maldives?
Your response must be concise. -45.3. In the year 1987, what is the difference between the Production index(2004-2006) in Cambodia and Production index(2004-2006) in Cameroon?
Make the answer very short. -12.26. In the year 1987, what is the difference between the Production index(2004-2006) of Cambodia and Production index(2004-2006) of Colombia?
Provide a short and direct response. -31.1. In the year 1987, what is the difference between the Production index(2004-2006) in Cambodia and Production index(2004-2006) in Maldives?
Ensure brevity in your answer.  -72.13. In the year 1987, what is the difference between the Production index(2004-2006) of Cameroon and Production index(2004-2006) of Colombia?
Give a very brief answer. -18.84. In the year 1987, what is the difference between the Production index(2004-2006) of Cameroon and Production index(2004-2006) of Maldives?
Your answer should be compact. -59.87. In the year 1987, what is the difference between the Production index(2004-2006) in Colombia and Production index(2004-2006) in Maldives?
Your response must be concise. -41.03. In the year 1988, what is the difference between the Production index(2004-2006) of Cambodia and Production index(2004-2006) of Cameroon?
Make the answer very short. -4.52. In the year 1988, what is the difference between the Production index(2004-2006) of Cambodia and Production index(2004-2006) of Colombia?
Offer a very short reply. -23.31. In the year 1988, what is the difference between the Production index(2004-2006) in Cambodia and Production index(2004-2006) in Maldives?
Provide a succinct answer. -62.84. In the year 1988, what is the difference between the Production index(2004-2006) in Cameroon and Production index(2004-2006) in Colombia?
Your response must be concise. -18.79. In the year 1988, what is the difference between the Production index(2004-2006) in Cameroon and Production index(2004-2006) in Maldives?
Offer a very short reply. -58.32. In the year 1988, what is the difference between the Production index(2004-2006) in Colombia and Production index(2004-2006) in Maldives?
Keep it short and to the point. -39.53. In the year 1989, what is the difference between the Production index(2004-2006) in Cambodia and Production index(2004-2006) in Cameroon?
Ensure brevity in your answer.  -3.89. In the year 1989, what is the difference between the Production index(2004-2006) in Cambodia and Production index(2004-2006) in Colombia?
Ensure brevity in your answer.  -25.52. In the year 1989, what is the difference between the Production index(2004-2006) in Cambodia and Production index(2004-2006) in Maldives?
Offer a terse response. -56.89. In the year 1989, what is the difference between the Production index(2004-2006) in Cameroon and Production index(2004-2006) in Colombia?
Offer a very short reply. -21.63. In the year 1989, what is the difference between the Production index(2004-2006) in Cameroon and Production index(2004-2006) in Maldives?
Offer a very short reply. -53. In the year 1989, what is the difference between the Production index(2004-2006) in Colombia and Production index(2004-2006) in Maldives?
Ensure brevity in your answer.  -31.37. In the year 1990, what is the difference between the Production index(2004-2006) in Cambodia and Production index(2004-2006) in Cameroon?
Offer a terse response. -7.48. In the year 1990, what is the difference between the Production index(2004-2006) in Cambodia and Production index(2004-2006) in Colombia?
Offer a terse response. -31.77. In the year 1990, what is the difference between the Production index(2004-2006) of Cambodia and Production index(2004-2006) of Maldives?
Your response must be concise. -26.72. In the year 1990, what is the difference between the Production index(2004-2006) of Cameroon and Production index(2004-2006) of Colombia?
Provide a short and direct response. -24.29. In the year 1990, what is the difference between the Production index(2004-2006) in Cameroon and Production index(2004-2006) in Maldives?
Ensure brevity in your answer.  -19.24. In the year 1990, what is the difference between the Production index(2004-2006) in Colombia and Production index(2004-2006) in Maldives?
Ensure brevity in your answer.  5.05. In the year 1991, what is the difference between the Production index(2004-2006) in Cambodia and Production index(2004-2006) in Cameroon?
Keep it short and to the point. -10.17. In the year 1991, what is the difference between the Production index(2004-2006) in Cambodia and Production index(2004-2006) in Colombia?
Ensure brevity in your answer.  -35.09. In the year 1991, what is the difference between the Production index(2004-2006) of Cambodia and Production index(2004-2006) of Maldives?
Offer a terse response. -24.29. In the year 1991, what is the difference between the Production index(2004-2006) of Cameroon and Production index(2004-2006) of Colombia?
Offer a very short reply. -24.92. In the year 1991, what is the difference between the Production index(2004-2006) of Cameroon and Production index(2004-2006) of Maldives?
Provide a short and direct response. -14.12. What is the ratio of the Production index(2004-2006) of Cambodia in 1984 to that in 1985?
Your response must be concise. 0.75. What is the ratio of the Production index(2004-2006) in Cameroon in 1984 to that in 1985?
Offer a terse response. 0.94. What is the ratio of the Production index(2004-2006) in Colombia in 1984 to that in 1985?
Provide a short and direct response. 1.03. What is the ratio of the Production index(2004-2006) of Maldives in 1984 to that in 1985?
Your response must be concise. 0.98. What is the ratio of the Production index(2004-2006) in Cambodia in 1984 to that in 1986?
Ensure brevity in your answer.  0.66. What is the ratio of the Production index(2004-2006) of Cameroon in 1984 to that in 1986?
Keep it short and to the point. 0.87. What is the ratio of the Production index(2004-2006) in Colombia in 1984 to that in 1986?
Your response must be concise. 0.99. What is the ratio of the Production index(2004-2006) in Maldives in 1984 to that in 1986?
Give a very brief answer. 0.97. What is the ratio of the Production index(2004-2006) in Cambodia in 1984 to that in 1987?
Give a very brief answer. 0.73. What is the ratio of the Production index(2004-2006) of Cameroon in 1984 to that in 1987?
Offer a very short reply. 1.01. What is the ratio of the Production index(2004-2006) of Colombia in 1984 to that in 1987?
Your response must be concise. 0.98. What is the ratio of the Production index(2004-2006) of Cambodia in 1984 to that in 1988?
Provide a succinct answer. 0.56. What is the ratio of the Production index(2004-2006) in Colombia in 1984 to that in 1988?
Offer a terse response. 0.93. What is the ratio of the Production index(2004-2006) of Maldives in 1984 to that in 1988?
Ensure brevity in your answer.  0.99. What is the ratio of the Production index(2004-2006) of Cambodia in 1984 to that in 1989?
Keep it short and to the point. 0.54. What is the ratio of the Production index(2004-2006) of Cameroon in 1984 to that in 1989?
Ensure brevity in your answer.  0.93. What is the ratio of the Production index(2004-2006) in Colombia in 1984 to that in 1989?
Your response must be concise. 0.89. What is the ratio of the Production index(2004-2006) of Maldives in 1984 to that in 1989?
Ensure brevity in your answer.  1.03. What is the ratio of the Production index(2004-2006) of Cambodia in 1984 to that in 1990?
Give a very brief answer. 0.56. What is the ratio of the Production index(2004-2006) of Cameroon in 1984 to that in 1990?
Provide a short and direct response. 0.9. What is the ratio of the Production index(2004-2006) in Colombia in 1984 to that in 1990?
Make the answer very short. 0.83. What is the ratio of the Production index(2004-2006) in Maldives in 1984 to that in 1990?
Offer a terse response. 1.47. What is the ratio of the Production index(2004-2006) in Cambodia in 1984 to that in 1991?
Provide a succinct answer. 0.57. What is the ratio of the Production index(2004-2006) in Cameroon in 1984 to that in 1991?
Give a very brief answer. 0.87. What is the ratio of the Production index(2004-2006) in Colombia in 1984 to that in 1991?
Ensure brevity in your answer.  0.81. What is the ratio of the Production index(2004-2006) of Maldives in 1984 to that in 1991?
Keep it short and to the point. 1.54. What is the ratio of the Production index(2004-2006) in Cambodia in 1985 to that in 1986?
Ensure brevity in your answer.  0.88. What is the ratio of the Production index(2004-2006) in Cameroon in 1985 to that in 1986?
Provide a short and direct response. 0.92. What is the ratio of the Production index(2004-2006) in Colombia in 1985 to that in 1986?
Provide a succinct answer. 0.95. What is the ratio of the Production index(2004-2006) of Maldives in 1985 to that in 1986?
Keep it short and to the point. 0.99. What is the ratio of the Production index(2004-2006) of Cambodia in 1985 to that in 1987?
Provide a succinct answer. 0.97. What is the ratio of the Production index(2004-2006) in Cameroon in 1985 to that in 1987?
Make the answer very short. 1.07. What is the ratio of the Production index(2004-2006) of Colombia in 1985 to that in 1987?
Offer a very short reply. 0.94. What is the ratio of the Production index(2004-2006) in Maldives in 1985 to that in 1987?
Your answer should be compact. 1.02. What is the ratio of the Production index(2004-2006) in Cambodia in 1985 to that in 1988?
Ensure brevity in your answer.  0.75. What is the ratio of the Production index(2004-2006) in Cameroon in 1985 to that in 1988?
Give a very brief answer. 1.01. What is the ratio of the Production index(2004-2006) of Colombia in 1985 to that in 1988?
Provide a short and direct response. 0.9. What is the ratio of the Production index(2004-2006) in Cambodia in 1985 to that in 1989?
Ensure brevity in your answer.  0.73. What is the ratio of the Production index(2004-2006) of Colombia in 1985 to that in 1989?
Offer a very short reply. 0.86. What is the ratio of the Production index(2004-2006) in Maldives in 1985 to that in 1989?
Ensure brevity in your answer.  1.05. What is the ratio of the Production index(2004-2006) in Cambodia in 1985 to that in 1990?
Provide a short and direct response. 0.75. What is the ratio of the Production index(2004-2006) in Cameroon in 1985 to that in 1990?
Offer a very short reply. 0.96. What is the ratio of the Production index(2004-2006) in Colombia in 1985 to that in 1990?
Your answer should be very brief. 0.81. What is the ratio of the Production index(2004-2006) in Maldives in 1985 to that in 1990?
Offer a very short reply. 1.5. What is the ratio of the Production index(2004-2006) in Cambodia in 1985 to that in 1991?
Your answer should be compact. 0.77. What is the ratio of the Production index(2004-2006) of Cameroon in 1985 to that in 1991?
Keep it short and to the point. 0.93. What is the ratio of the Production index(2004-2006) in Colombia in 1985 to that in 1991?
Make the answer very short. 0.78. What is the ratio of the Production index(2004-2006) in Maldives in 1985 to that in 1991?
Ensure brevity in your answer.  1.57. What is the ratio of the Production index(2004-2006) of Cambodia in 1986 to that in 1987?
Provide a succinct answer. 1.1. What is the ratio of the Production index(2004-2006) of Cameroon in 1986 to that in 1987?
Give a very brief answer. 1.17. What is the ratio of the Production index(2004-2006) of Colombia in 1986 to that in 1987?
Your answer should be compact. 0.99. What is the ratio of the Production index(2004-2006) in Maldives in 1986 to that in 1987?
Offer a very short reply. 1.03. What is the ratio of the Production index(2004-2006) of Cambodia in 1986 to that in 1988?
Offer a terse response. 0.85. What is the ratio of the Production index(2004-2006) of Cameroon in 1986 to that in 1988?
Your answer should be very brief. 1.1. What is the ratio of the Production index(2004-2006) of Colombia in 1986 to that in 1988?
Make the answer very short. 0.95. What is the ratio of the Production index(2004-2006) in Maldives in 1986 to that in 1988?
Provide a succinct answer. 1.02. What is the ratio of the Production index(2004-2006) in Cambodia in 1986 to that in 1989?
Offer a terse response. 0.82. What is the ratio of the Production index(2004-2006) in Cameroon in 1986 to that in 1989?
Your answer should be very brief. 1.08. What is the ratio of the Production index(2004-2006) of Colombia in 1986 to that in 1989?
Offer a terse response. 0.9. What is the ratio of the Production index(2004-2006) in Maldives in 1986 to that in 1989?
Ensure brevity in your answer.  1.06. What is the ratio of the Production index(2004-2006) of Cambodia in 1986 to that in 1990?
Your answer should be compact. 0.85. What is the ratio of the Production index(2004-2006) of Cameroon in 1986 to that in 1990?
Your answer should be very brief. 1.04. What is the ratio of the Production index(2004-2006) in Colombia in 1986 to that in 1990?
Offer a terse response. 0.84. What is the ratio of the Production index(2004-2006) in Maldives in 1986 to that in 1990?
Offer a terse response. 1.52. What is the ratio of the Production index(2004-2006) of Cambodia in 1986 to that in 1991?
Offer a terse response. 0.87. What is the ratio of the Production index(2004-2006) of Colombia in 1986 to that in 1991?
Keep it short and to the point. 0.82. What is the ratio of the Production index(2004-2006) in Maldives in 1986 to that in 1991?
Offer a very short reply. 1.59. What is the ratio of the Production index(2004-2006) in Cambodia in 1987 to that in 1988?
Provide a succinct answer. 0.77. What is the ratio of the Production index(2004-2006) of Cameroon in 1987 to that in 1988?
Provide a succinct answer. 0.94. What is the ratio of the Production index(2004-2006) in Colombia in 1987 to that in 1988?
Ensure brevity in your answer.  0.96. What is the ratio of the Production index(2004-2006) of Maldives in 1987 to that in 1988?
Ensure brevity in your answer.  0.99. What is the ratio of the Production index(2004-2006) in Cambodia in 1987 to that in 1989?
Provide a short and direct response. 0.75. What is the ratio of the Production index(2004-2006) of Cameroon in 1987 to that in 1989?
Offer a terse response. 0.92. What is the ratio of the Production index(2004-2006) in Maldives in 1987 to that in 1989?
Your response must be concise. 1.03. What is the ratio of the Production index(2004-2006) of Cambodia in 1987 to that in 1990?
Give a very brief answer. 0.77. What is the ratio of the Production index(2004-2006) in Cameroon in 1987 to that in 1990?
Your answer should be very brief. 0.89. What is the ratio of the Production index(2004-2006) in Colombia in 1987 to that in 1990?
Give a very brief answer. 0.85. What is the ratio of the Production index(2004-2006) in Maldives in 1987 to that in 1990?
Give a very brief answer. 1.47. What is the ratio of the Production index(2004-2006) of Cambodia in 1987 to that in 1991?
Make the answer very short. 0.79. What is the ratio of the Production index(2004-2006) in Cameroon in 1987 to that in 1991?
Give a very brief answer. 0.86. What is the ratio of the Production index(2004-2006) of Colombia in 1987 to that in 1991?
Ensure brevity in your answer.  0.83. What is the ratio of the Production index(2004-2006) of Maldives in 1987 to that in 1991?
Offer a terse response. 1.54. What is the ratio of the Production index(2004-2006) of Cambodia in 1988 to that in 1989?
Give a very brief answer. 0.97. What is the ratio of the Production index(2004-2006) of Cameroon in 1988 to that in 1989?
Make the answer very short. 0.98. What is the ratio of the Production index(2004-2006) of Colombia in 1988 to that in 1989?
Your answer should be compact. 0.95. What is the ratio of the Production index(2004-2006) of Maldives in 1988 to that in 1989?
Give a very brief answer. 1.04. What is the ratio of the Production index(2004-2006) of Cambodia in 1988 to that in 1990?
Offer a terse response. 1. What is the ratio of the Production index(2004-2006) of Cameroon in 1988 to that in 1990?
Make the answer very short. 0.95. What is the ratio of the Production index(2004-2006) in Colombia in 1988 to that in 1990?
Offer a very short reply. 0.89. What is the ratio of the Production index(2004-2006) in Maldives in 1988 to that in 1990?
Your answer should be compact. 1.49. What is the ratio of the Production index(2004-2006) in Cambodia in 1988 to that in 1991?
Your answer should be very brief. 1.02. What is the ratio of the Production index(2004-2006) in Cameroon in 1988 to that in 1991?
Provide a succinct answer. 0.92. What is the ratio of the Production index(2004-2006) in Colombia in 1988 to that in 1991?
Your answer should be very brief. 0.87. What is the ratio of the Production index(2004-2006) in Maldives in 1988 to that in 1991?
Provide a succinct answer. 1.56. What is the ratio of the Production index(2004-2006) in Cambodia in 1989 to that in 1990?
Your response must be concise. 1.03. What is the ratio of the Production index(2004-2006) of Cameroon in 1989 to that in 1990?
Your answer should be very brief. 0.96. What is the ratio of the Production index(2004-2006) of Colombia in 1989 to that in 1990?
Make the answer very short. 0.94. What is the ratio of the Production index(2004-2006) of Maldives in 1989 to that in 1990?
Ensure brevity in your answer.  1.43. What is the ratio of the Production index(2004-2006) in Cambodia in 1989 to that in 1991?
Your answer should be compact. 1.06. What is the ratio of the Production index(2004-2006) of Cameroon in 1989 to that in 1991?
Your answer should be compact. 0.94. What is the ratio of the Production index(2004-2006) of Colombia in 1989 to that in 1991?
Your answer should be compact. 0.91. What is the ratio of the Production index(2004-2006) in Maldives in 1989 to that in 1991?
Offer a terse response. 1.5. What is the ratio of the Production index(2004-2006) of Cambodia in 1990 to that in 1991?
Make the answer very short. 1.02. What is the ratio of the Production index(2004-2006) of Cameroon in 1990 to that in 1991?
Keep it short and to the point. 0.97. What is the ratio of the Production index(2004-2006) in Colombia in 1990 to that in 1991?
Your response must be concise. 0.97. What is the ratio of the Production index(2004-2006) of Maldives in 1990 to that in 1991?
Provide a succinct answer. 1.05. What is the difference between the highest and the second highest Production index(2004-2006) in Cambodia?
Make the answer very short. 1.52. What is the difference between the highest and the second highest Production index(2004-2006) in Cameroon?
Your answer should be very brief. 0.45. What is the difference between the highest and the second highest Production index(2004-2006) of Colombia?
Your answer should be very brief. 2.23. What is the difference between the highest and the second highest Production index(2004-2006) in Maldives?
Make the answer very short. 1.43. What is the difference between the highest and the lowest Production index(2004-2006) in Cambodia?
Provide a succinct answer. 22.23. What is the difference between the highest and the lowest Production index(2004-2006) of Cameroon?
Keep it short and to the point. 8.04. What is the difference between the highest and the lowest Production index(2004-2006) of Colombia?
Provide a succinct answer. 17.55. What is the difference between the highest and the lowest Production index(2004-2006) in Maldives?
Offer a terse response. 41.63. 